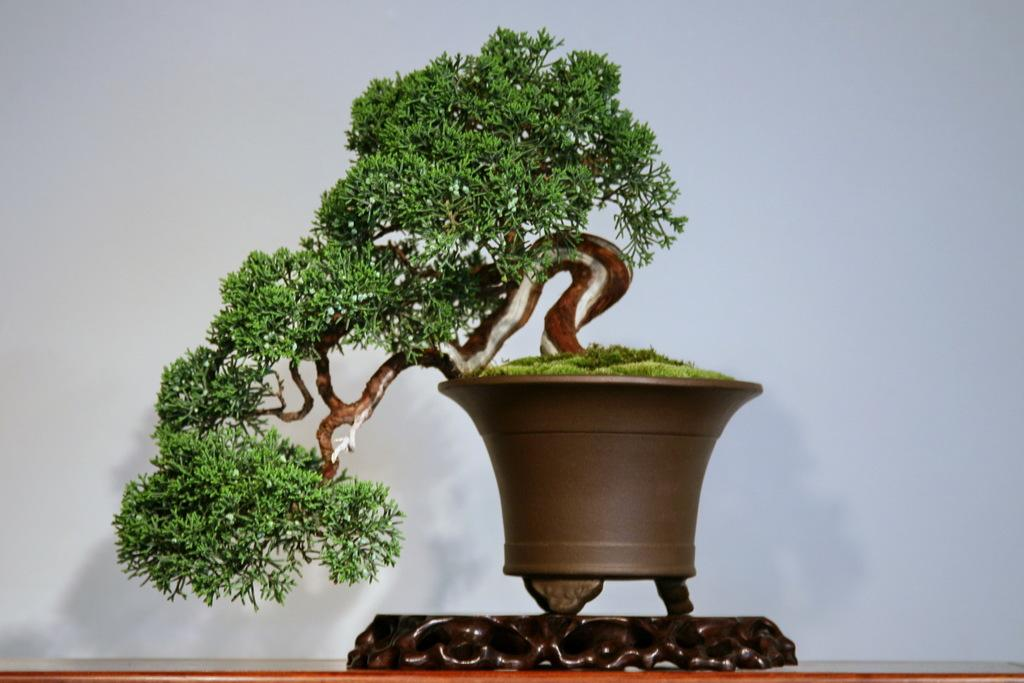What is located in the front of the image? There is a plant in the front of the image. What can be seen in the background of the image? There appears to be a wall in the background of the image. How many boys are touching the plant in the image? There are no boys present in the image, and therefore no one is touching the plant. What type of army is depicted in the image? There is no army depicted in the image; it features a plant and a wall. 